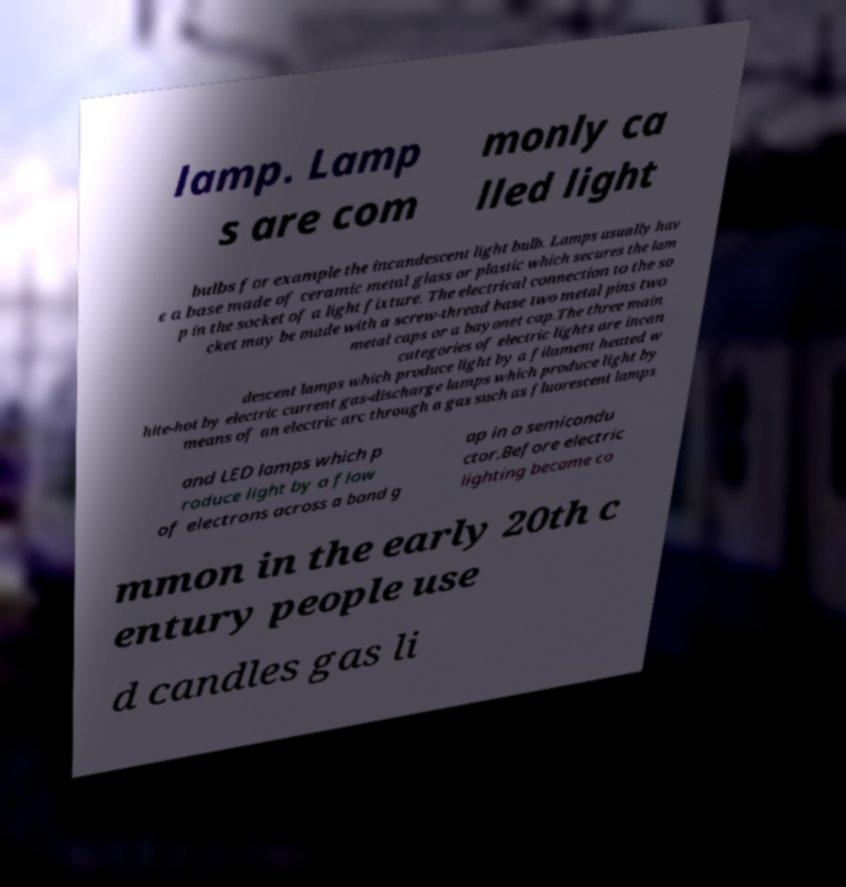Please identify and transcribe the text found in this image. lamp. Lamp s are com monly ca lled light bulbs for example the incandescent light bulb. Lamps usually hav e a base made of ceramic metal glass or plastic which secures the lam p in the socket of a light fixture. The electrical connection to the so cket may be made with a screw-thread base two metal pins two metal caps or a bayonet cap.The three main categories of electric lights are incan descent lamps which produce light by a filament heated w hite-hot by electric current gas-discharge lamps which produce light by means of an electric arc through a gas such as fluorescent lamps and LED lamps which p roduce light by a flow of electrons across a band g ap in a semicondu ctor.Before electric lighting became co mmon in the early 20th c entury people use d candles gas li 